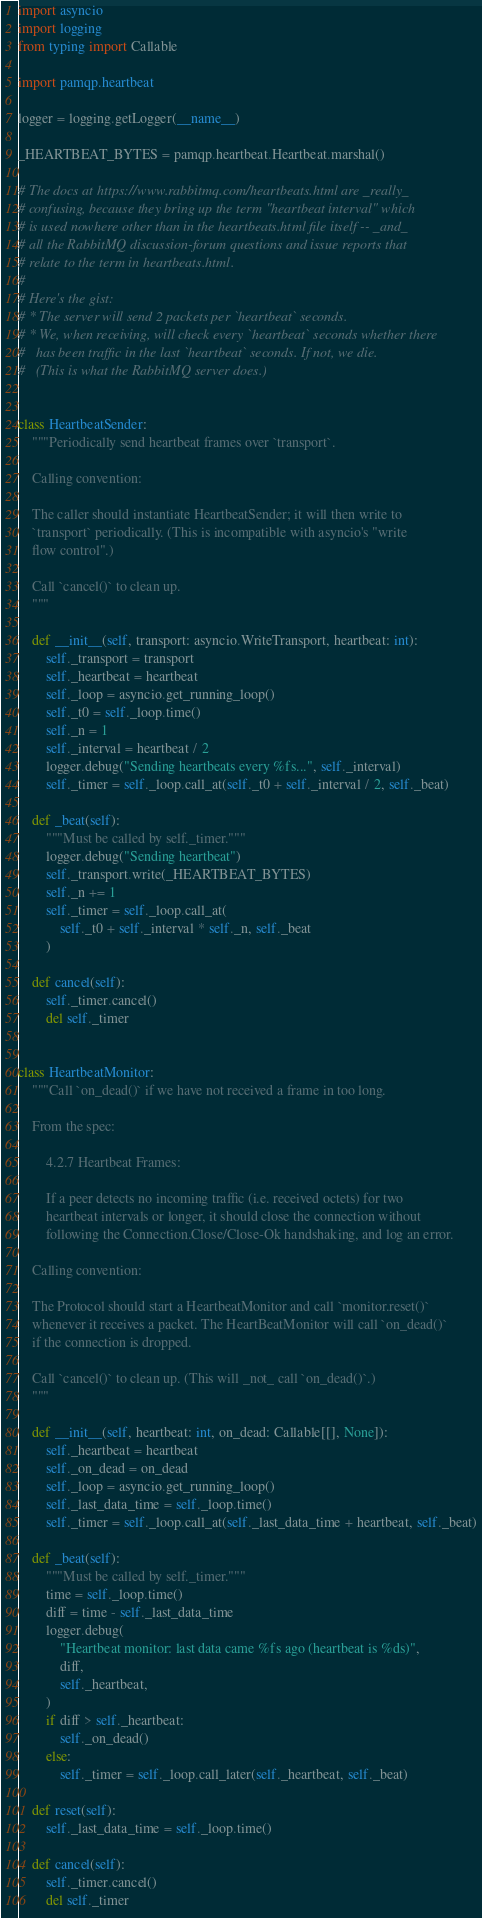Convert code to text. <code><loc_0><loc_0><loc_500><loc_500><_Python_>import asyncio
import logging
from typing import Callable

import pamqp.heartbeat

logger = logging.getLogger(__name__)

_HEARTBEAT_BYTES = pamqp.heartbeat.Heartbeat.marshal()

# The docs at https://www.rabbitmq.com/heartbeats.html are _really_
# confusing, because they bring up the term "heartbeat interval" which
# is used nowhere other than in the heartbeats.html file itself -- _and_
# all the RabbitMQ discussion-forum questions and issue reports that
# relate to the term in heartbeats.html.
#
# Here's the gist:
# * The server will send 2 packets per `heartbeat` seconds.
# * We, when receiving, will check every `heartbeat` seconds whether there
#   has been traffic in the last `heartbeat` seconds. If not, we die.
#   (This is what the RabbitMQ server does.)


class HeartbeatSender:
    """Periodically send heartbeat frames over `transport`.

    Calling convention:

    The caller should instantiate HeartbeatSender; it will then write to
    `transport` periodically. (This is incompatible with asyncio's "write
    flow control".)

    Call `cancel()` to clean up.
    """

    def __init__(self, transport: asyncio.WriteTransport, heartbeat: int):
        self._transport = transport
        self._heartbeat = heartbeat
        self._loop = asyncio.get_running_loop()
        self._t0 = self._loop.time()
        self._n = 1
        self._interval = heartbeat / 2
        logger.debug("Sending heartbeats every %fs...", self._interval)
        self._timer = self._loop.call_at(self._t0 + self._interval / 2, self._beat)

    def _beat(self):
        """Must be called by self._timer."""
        logger.debug("Sending heartbeat")
        self._transport.write(_HEARTBEAT_BYTES)
        self._n += 1
        self._timer = self._loop.call_at(
            self._t0 + self._interval * self._n, self._beat
        )

    def cancel(self):
        self._timer.cancel()
        del self._timer


class HeartbeatMonitor:
    """Call `on_dead()` if we have not received a frame in too long.

    From the spec:

        4.2.7 Heartbeat Frames:

        If a peer detects no incoming traffic (i.e. received octets) for two
        heartbeat intervals or longer, it should close the connection without
        following the Connection.Close/Close-Ok handshaking, and log an error.

    Calling convention:

    The Protocol should start a HeartbeatMonitor and call `monitor.reset()`
    whenever it receives a packet. The HeartBeatMonitor will call `on_dead()`
    if the connection is dropped.

    Call `cancel()` to clean up. (This will _not_ call `on_dead()`.)
    """

    def __init__(self, heartbeat: int, on_dead: Callable[[], None]):
        self._heartbeat = heartbeat
        self._on_dead = on_dead
        self._loop = asyncio.get_running_loop()
        self._last_data_time = self._loop.time()
        self._timer = self._loop.call_at(self._last_data_time + heartbeat, self._beat)

    def _beat(self):
        """Must be called by self._timer."""
        time = self._loop.time()
        diff = time - self._last_data_time
        logger.debug(
            "Heartbeat monitor: last data came %fs ago (heartbeat is %ds)",
            diff,
            self._heartbeat,
        )
        if diff > self._heartbeat:
            self._on_dead()
        else:
            self._timer = self._loop.call_later(self._heartbeat, self._beat)

    def reset(self):
        self._last_data_time = self._loop.time()

    def cancel(self):
        self._timer.cancel()
        del self._timer
</code> 